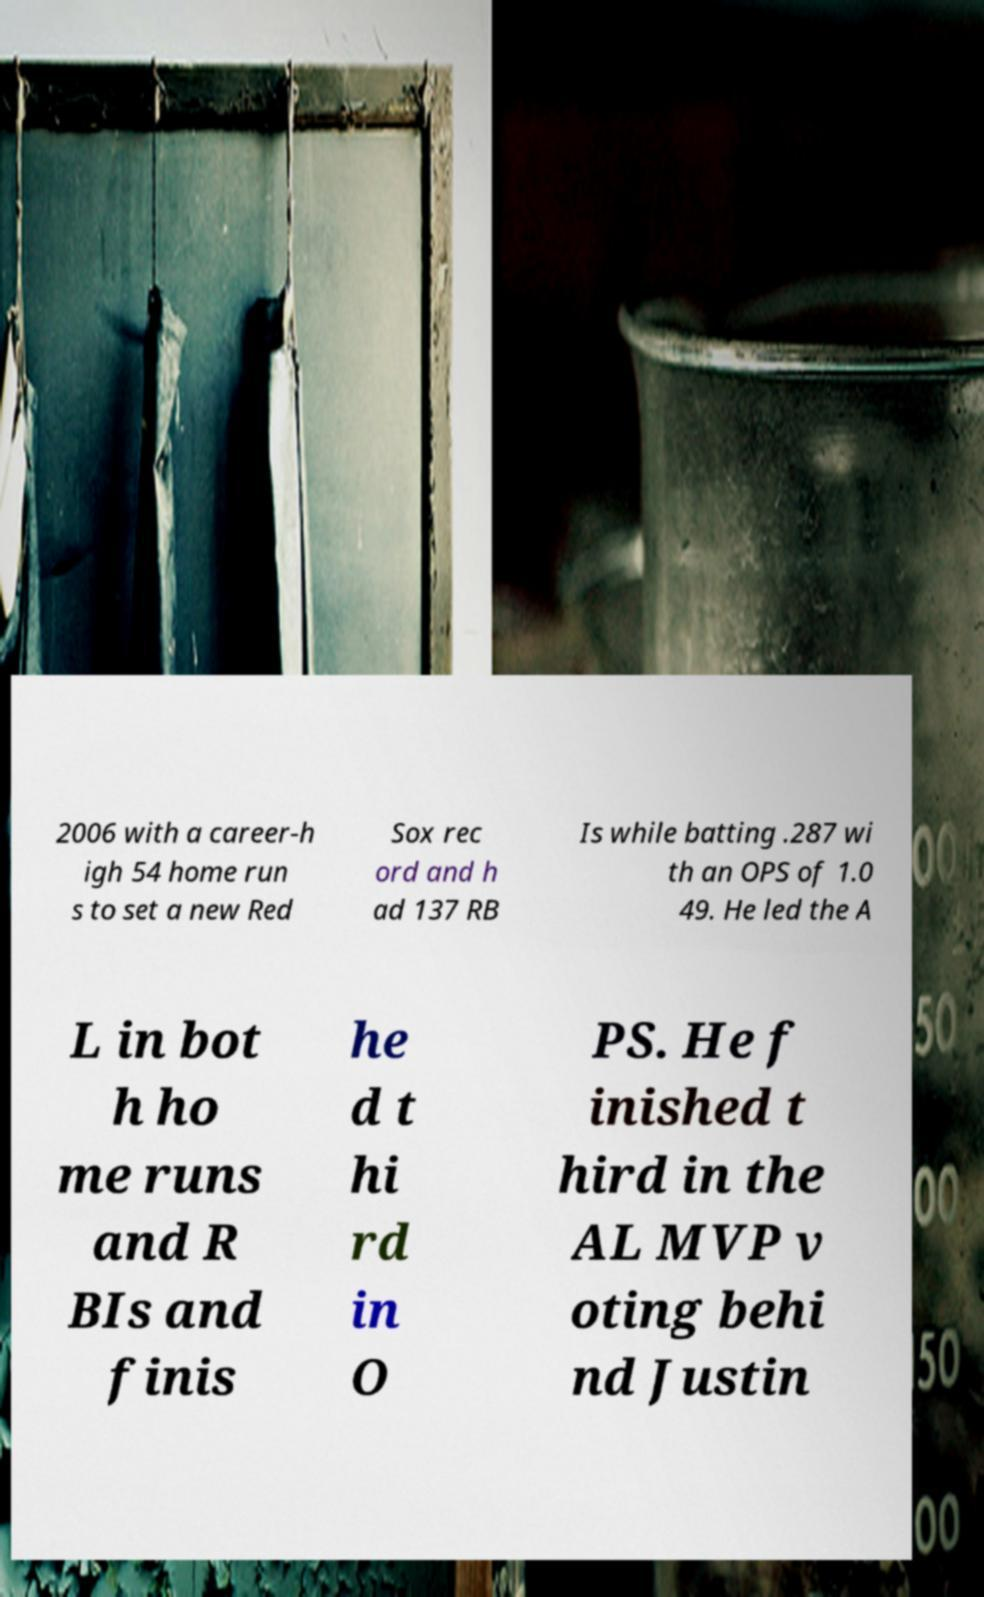What messages or text are displayed in this image? I need them in a readable, typed format. 2006 with a career-h igh 54 home run s to set a new Red Sox rec ord and h ad 137 RB Is while batting .287 wi th an OPS of 1.0 49. He led the A L in bot h ho me runs and R BIs and finis he d t hi rd in O PS. He f inished t hird in the AL MVP v oting behi nd Justin 